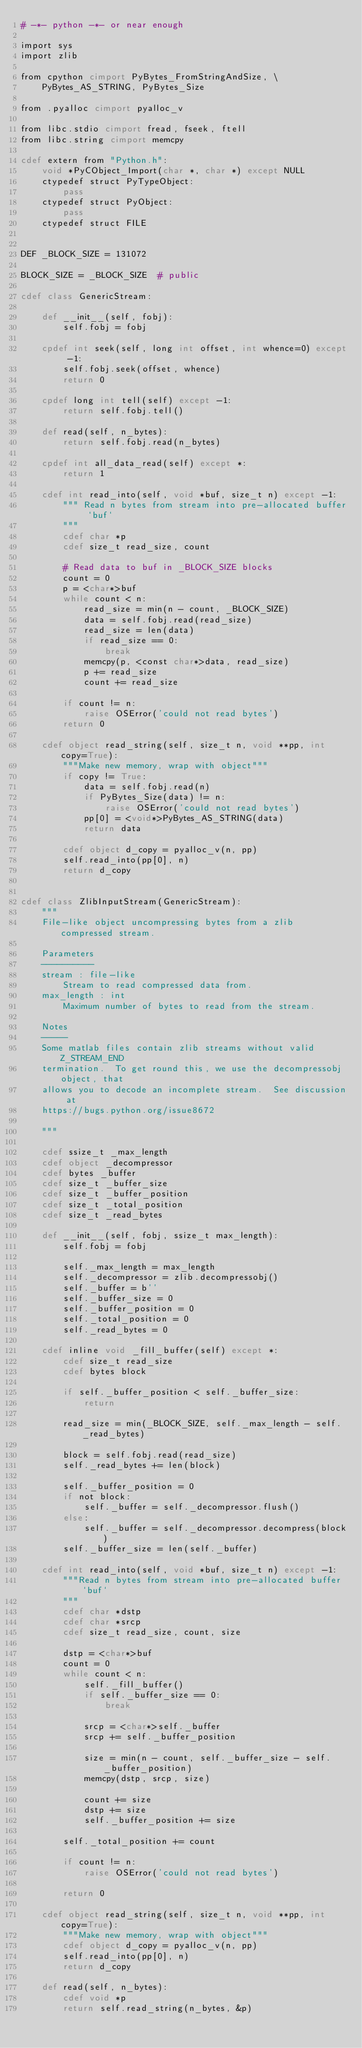Convert code to text. <code><loc_0><loc_0><loc_500><loc_500><_Cython_># -*- python -*- or near enough

import sys
import zlib

from cpython cimport PyBytes_FromStringAndSize, \
    PyBytes_AS_STRING, PyBytes_Size

from .pyalloc cimport pyalloc_v

from libc.stdio cimport fread, fseek, ftell
from libc.string cimport memcpy

cdef extern from "Python.h":
    void *PyCObject_Import(char *, char *) except NULL
    ctypedef struct PyTypeObject:
        pass
    ctypedef struct PyObject:
        pass
    ctypedef struct FILE


DEF _BLOCK_SIZE = 131072

BLOCK_SIZE = _BLOCK_SIZE  # public

cdef class GenericStream:

    def __init__(self, fobj):
        self.fobj = fobj

    cpdef int seek(self, long int offset, int whence=0) except -1:
        self.fobj.seek(offset, whence)
        return 0

    cpdef long int tell(self) except -1:
        return self.fobj.tell()

    def read(self, n_bytes):
        return self.fobj.read(n_bytes)

    cpdef int all_data_read(self) except *:
        return 1

    cdef int read_into(self, void *buf, size_t n) except -1:
        """ Read n bytes from stream into pre-allocated buffer `buf`
        """
        cdef char *p
        cdef size_t read_size, count

        # Read data to buf in _BLOCK_SIZE blocks
        count = 0
        p = <char*>buf
        while count < n:
            read_size = min(n - count, _BLOCK_SIZE)
            data = self.fobj.read(read_size)
            read_size = len(data)
            if read_size == 0:
                break
            memcpy(p, <const char*>data, read_size)
            p += read_size
            count += read_size

        if count != n:
            raise OSError('could not read bytes')
        return 0

    cdef object read_string(self, size_t n, void **pp, int copy=True):
        """Make new memory, wrap with object"""
        if copy != True:
            data = self.fobj.read(n)
            if PyBytes_Size(data) != n:
                raise OSError('could not read bytes')
            pp[0] = <void*>PyBytes_AS_STRING(data)
            return data

        cdef object d_copy = pyalloc_v(n, pp)
        self.read_into(pp[0], n)
        return d_copy


cdef class ZlibInputStream(GenericStream):
    """
    File-like object uncompressing bytes from a zlib compressed stream.

    Parameters
    ----------
    stream : file-like
        Stream to read compressed data from.
    max_length : int
        Maximum number of bytes to read from the stream.

    Notes
    -----
    Some matlab files contain zlib streams without valid Z_STREAM_END
    termination.  To get round this, we use the decompressobj object, that
    allows you to decode an incomplete stream.  See discussion at
    https://bugs.python.org/issue8672

    """

    cdef ssize_t _max_length
    cdef object _decompressor
    cdef bytes _buffer
    cdef size_t _buffer_size
    cdef size_t _buffer_position
    cdef size_t _total_position
    cdef size_t _read_bytes

    def __init__(self, fobj, ssize_t max_length):
        self.fobj = fobj

        self._max_length = max_length
        self._decompressor = zlib.decompressobj()
        self._buffer = b''
        self._buffer_size = 0
        self._buffer_position = 0
        self._total_position = 0
        self._read_bytes = 0

    cdef inline void _fill_buffer(self) except *:
        cdef size_t read_size
        cdef bytes block

        if self._buffer_position < self._buffer_size:
            return

        read_size = min(_BLOCK_SIZE, self._max_length - self._read_bytes)

        block = self.fobj.read(read_size)
        self._read_bytes += len(block)

        self._buffer_position = 0
        if not block:
            self._buffer = self._decompressor.flush()
        else:
            self._buffer = self._decompressor.decompress(block)
        self._buffer_size = len(self._buffer)

    cdef int read_into(self, void *buf, size_t n) except -1:
        """Read n bytes from stream into pre-allocated buffer `buf`
        """
        cdef char *dstp
        cdef char *srcp
        cdef size_t read_size, count, size

        dstp = <char*>buf
        count = 0
        while count < n:
            self._fill_buffer()
            if self._buffer_size == 0:
                break

            srcp = <char*>self._buffer
            srcp += self._buffer_position

            size = min(n - count, self._buffer_size - self._buffer_position)
            memcpy(dstp, srcp, size)

            count += size
            dstp += size
            self._buffer_position += size

        self._total_position += count

        if count != n:
            raise OSError('could not read bytes')

        return 0

    cdef object read_string(self, size_t n, void **pp, int copy=True):
        """Make new memory, wrap with object"""
        cdef object d_copy = pyalloc_v(n, pp)
        self.read_into(pp[0], n)
        return d_copy

    def read(self, n_bytes):
        cdef void *p
        return self.read_string(n_bytes, &p)
</code> 